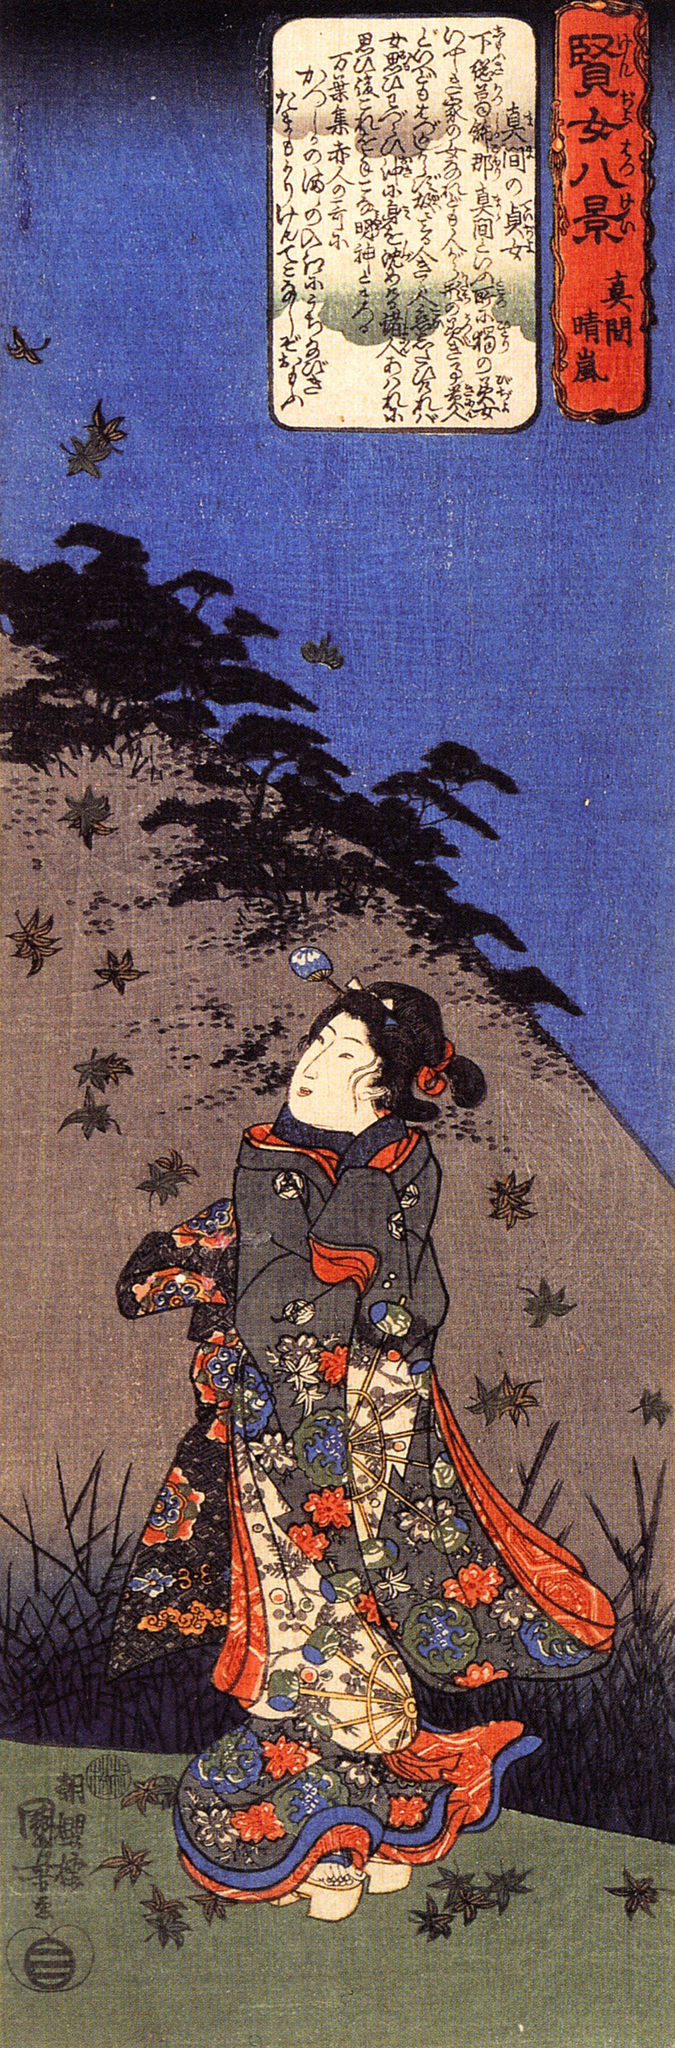If this image were part of a larger narrative, what role might the mountain play? If this image were part of a larger narrative, the mountain could symbolize a place of spiritual significance or a destination of a personal quest. It might represent a journey of self-discovery, where the woman in the vibrant kimono seeks enlightenment or a deeper understanding of herself and the world. The mountain, with its towering presence and the birds flying towards its peak, could be a metaphor for the challenges and aspirations that lie ahead. It serves as a poignant reminder of the balance between the tangible and ethereal, guiding the woman's journey both physically and spiritually. 